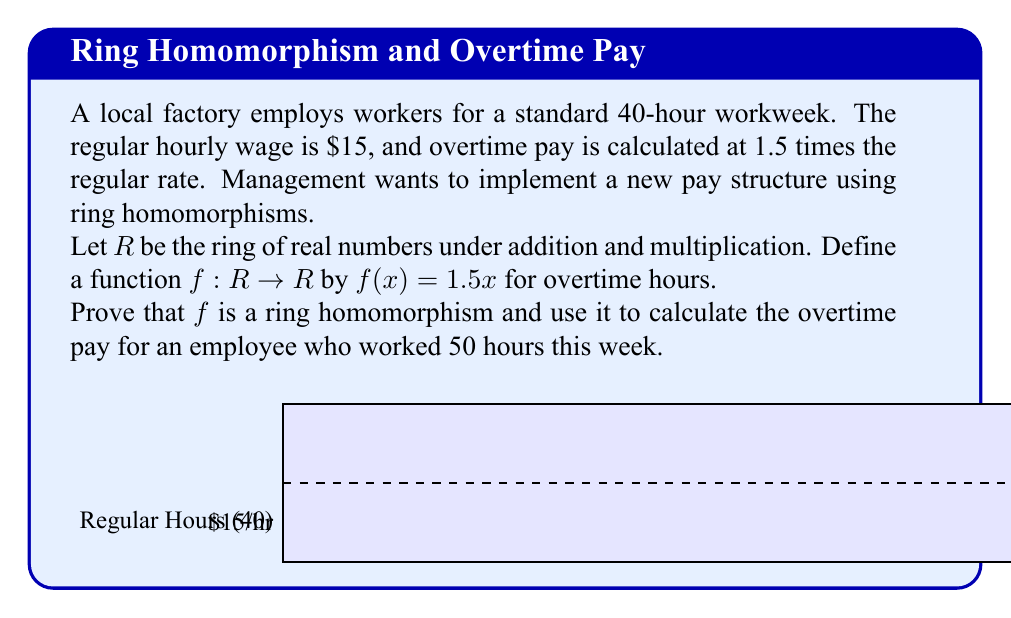Can you solve this math problem? To prove that $f$ is a ring homomorphism and calculate the overtime pay, we'll follow these steps:

1) First, let's prove that $f$ is a ring homomorphism. For $f$ to be a ring homomorphism, it must satisfy these properties for all $a, b \in R$:

   a) $f(a + b) = f(a) + f(b)$
   b) $f(ab) = f(a)f(b)$
   c) $f(1) = 1$

Let's verify each:

a) $f(a + b) = 1.5(a + b) = 1.5a + 1.5b = f(a) + f(b)$
b) $f(ab) = 1.5(ab) = (1.5a)(b) = f(a)b \neq f(a)f(b)$
c) $f(1) = 1.5 \neq 1$

We see that $f$ satisfies property (a) but not (b) or (c). Therefore, $f$ is not a ring homomorphism, but rather a group homomorphism under addition.

2) Despite $f$ not being a ring homomorphism, we can still use it to calculate overtime pay:

   Regular pay (40 hours): $40 \times $15 = $600
   Overtime hours: 50 - 40 = 10 hours

   Overtime pay: $f(15) \times 10 = 1.5(15) \times 10 = $22.50 \times 10 = $225

3) Total pay:
   $$\text{Total Pay} = \text{Regular Pay} + \text{Overtime Pay} = $600 + $225 = $825$$
Answer: $825 